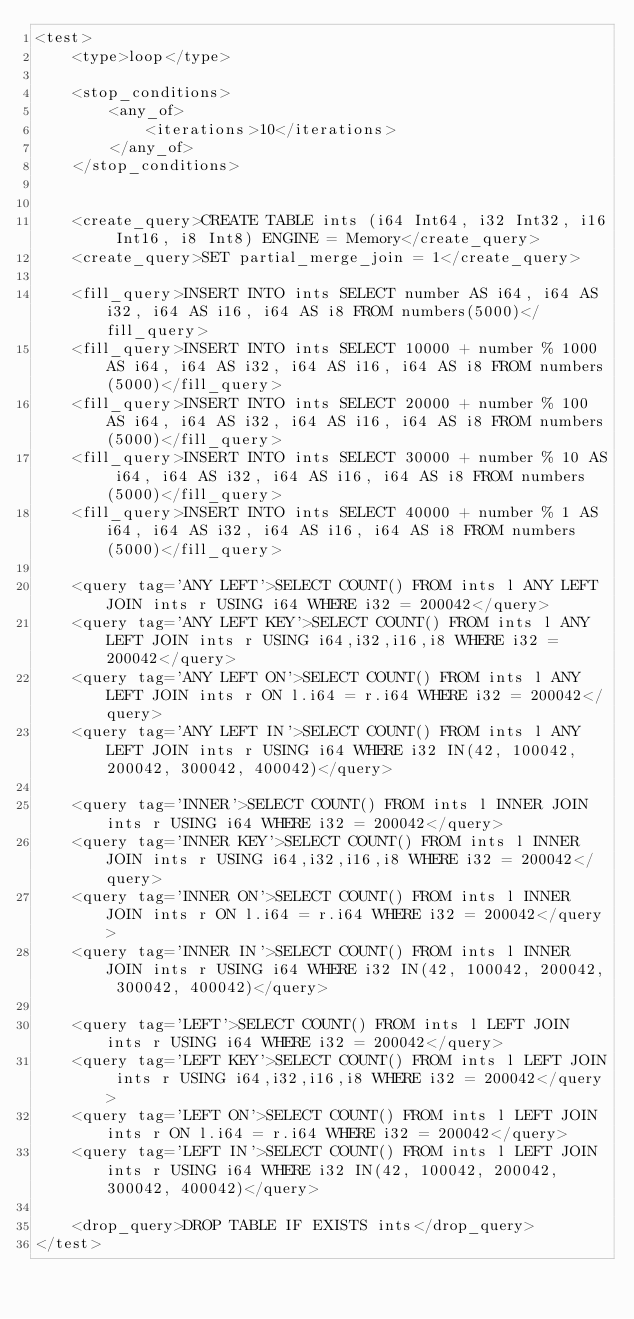<code> <loc_0><loc_0><loc_500><loc_500><_XML_><test>
    <type>loop</type>

    <stop_conditions>
        <any_of>
            <iterations>10</iterations>
        </any_of>
    </stop_conditions>


    <create_query>CREATE TABLE ints (i64 Int64, i32 Int32, i16 Int16, i8 Int8) ENGINE = Memory</create_query>
    <create_query>SET partial_merge_join = 1</create_query>

    <fill_query>INSERT INTO ints SELECT number AS i64, i64 AS i32, i64 AS i16, i64 AS i8 FROM numbers(5000)</fill_query>
    <fill_query>INSERT INTO ints SELECT 10000 + number % 1000 AS i64, i64 AS i32, i64 AS i16, i64 AS i8 FROM numbers(5000)</fill_query>
    <fill_query>INSERT INTO ints SELECT 20000 + number % 100 AS i64, i64 AS i32, i64 AS i16, i64 AS i8 FROM numbers(5000)</fill_query>
    <fill_query>INSERT INTO ints SELECT 30000 + number % 10 AS i64, i64 AS i32, i64 AS i16, i64 AS i8 FROM numbers(5000)</fill_query>
    <fill_query>INSERT INTO ints SELECT 40000 + number % 1 AS i64, i64 AS i32, i64 AS i16, i64 AS i8 FROM numbers(5000)</fill_query>

    <query tag='ANY LEFT'>SELECT COUNT() FROM ints l ANY LEFT JOIN ints r USING i64 WHERE i32 = 200042</query>
    <query tag='ANY LEFT KEY'>SELECT COUNT() FROM ints l ANY LEFT JOIN ints r USING i64,i32,i16,i8 WHERE i32 = 200042</query>
    <query tag='ANY LEFT ON'>SELECT COUNT() FROM ints l ANY LEFT JOIN ints r ON l.i64 = r.i64 WHERE i32 = 200042</query>
    <query tag='ANY LEFT IN'>SELECT COUNT() FROM ints l ANY LEFT JOIN ints r USING i64 WHERE i32 IN(42, 100042, 200042, 300042, 400042)</query>

    <query tag='INNER'>SELECT COUNT() FROM ints l INNER JOIN ints r USING i64 WHERE i32 = 200042</query>
    <query tag='INNER KEY'>SELECT COUNT() FROM ints l INNER JOIN ints r USING i64,i32,i16,i8 WHERE i32 = 200042</query>
    <query tag='INNER ON'>SELECT COUNT() FROM ints l INNER JOIN ints r ON l.i64 = r.i64 WHERE i32 = 200042</query>
    <query tag='INNER IN'>SELECT COUNT() FROM ints l INNER JOIN ints r USING i64 WHERE i32 IN(42, 100042, 200042, 300042, 400042)</query>

    <query tag='LEFT'>SELECT COUNT() FROM ints l LEFT JOIN ints r USING i64 WHERE i32 = 200042</query>
    <query tag='LEFT KEY'>SELECT COUNT() FROM ints l LEFT JOIN ints r USING i64,i32,i16,i8 WHERE i32 = 200042</query>
    <query tag='LEFT ON'>SELECT COUNT() FROM ints l LEFT JOIN ints r ON l.i64 = r.i64 WHERE i32 = 200042</query>
    <query tag='LEFT IN'>SELECT COUNT() FROM ints l LEFT JOIN ints r USING i64 WHERE i32 IN(42, 100042, 200042, 300042, 400042)</query>

    <drop_query>DROP TABLE IF EXISTS ints</drop_query>
</test>
</code> 